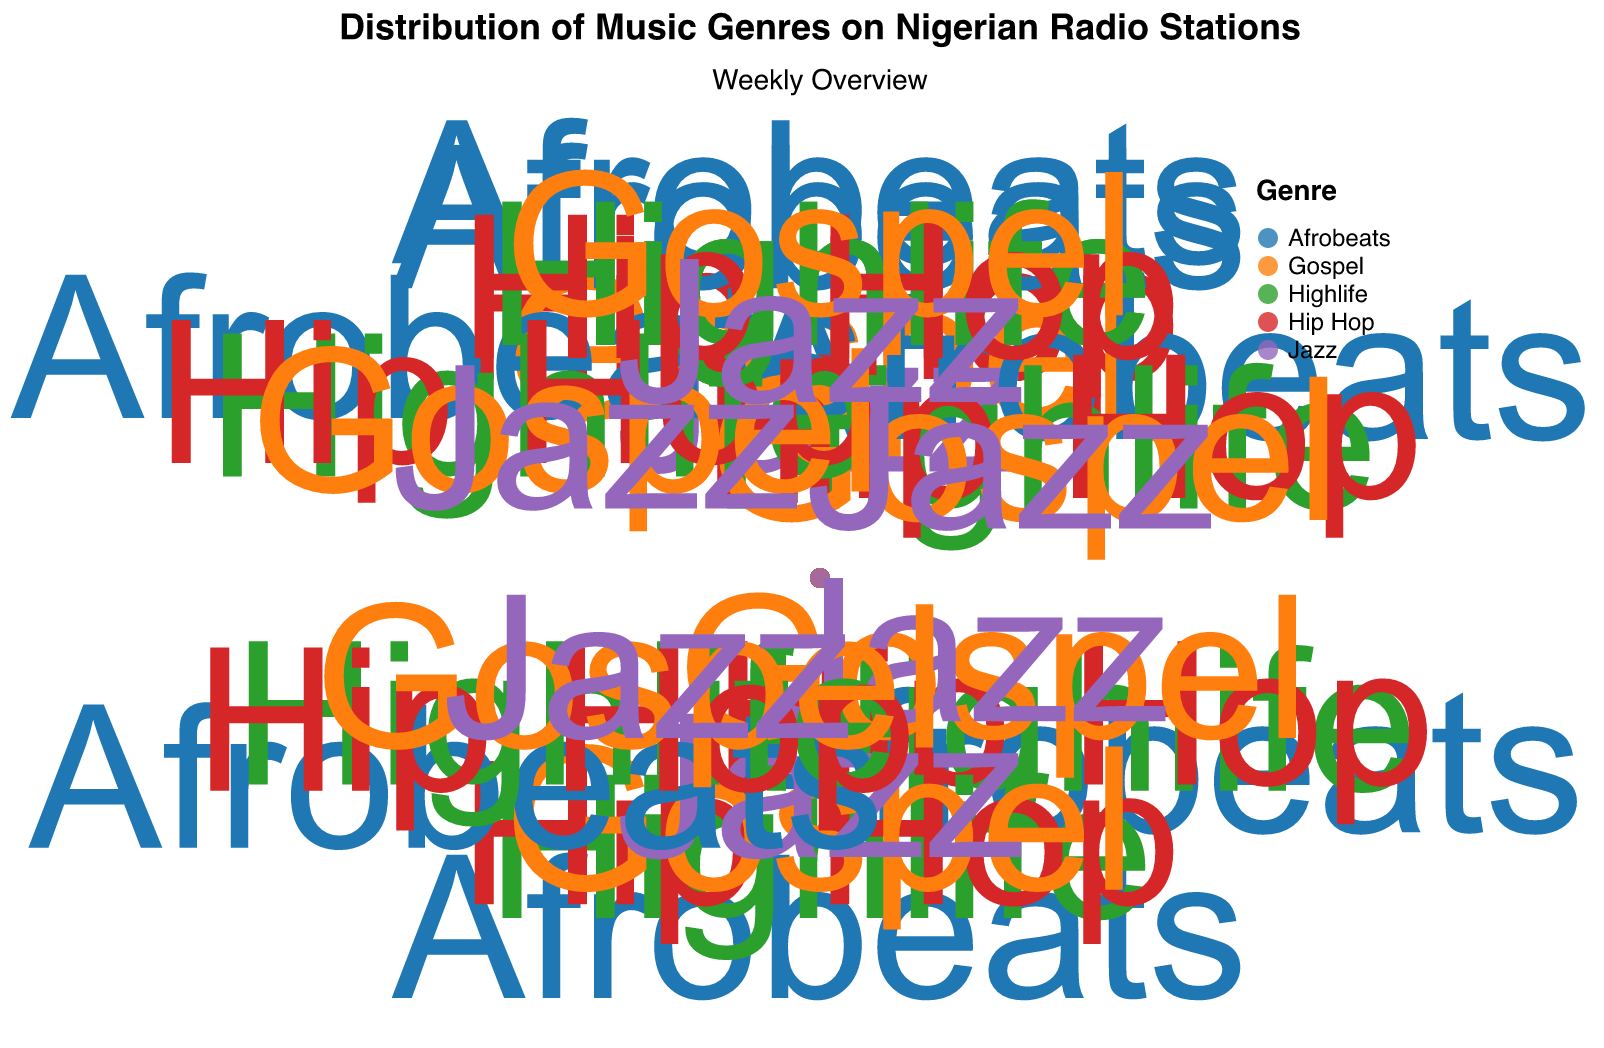What is the most frequently played genre on Monday? The points on Monday show Afrobeats with the highest frequency at 35.
Answer: Afrobeats What is the average frequency of Gospel music played from Monday to Friday? Sum the frequencies for Gospel music from Monday to Friday: 10 + 12 + 8 + 14 + 10 = 54, then divide by 5 to get the average: 54/5.
Answer: 10.8 Which day has the highest frequency of Jazz music? Check the frequencies of Jazz music on all days; Saturday has the highest frequency at 15.
Answer: Saturday How does the frequency of Afrobeats on Thursday compare to its frequency on Saturday? The frequency of Afrobeats on Thursday is 32, and on Saturday it is 50. Comparing these, Saturday has a higher frequency.
Answer: Saturday What is the total frequency of Highlife music played on the weekend (Saturday and Sunday)? Sum the frequencies of Highlife on Saturday (25) and Sunday (20): 25 + 20 = 45.
Answer: 45 Which genre sees the most significant increase in plays from Monday to Saturday? For each genre, calculate the difference in frequency from Monday to Saturday: Afrobeats (50-35=15), Highlife (25-20=5), Hip Hop (30-15=15), Gospel (20-10=10), Jazz (15-5=10). Both Afrobeats and Hip Hop have an increase of 15.
Answer: Afrobeats and Hip Hop What is the average frequency of all genres played on Wednesday? Sum the frequencies for all genres on Wednesday: Afrobeats (38) + Highlife (22) + Hip Hop (20) + Gospel (8) + Jazz (5) = 93. Divide by the number of genres (5): 93/5 = 18.6.
Answer: 18.6 Which genre has the smallest variation in frequency throughout the week? Calculate the range for each genre (max - min): Afrobeats (50-30=20), Highlife (25-15=10), Hip Hop (30-15=15), Gospel (25-8=17), Jazz (15-5=10). Highlife and Jazz both have the smallest variation of 10.
Answer: Highlife and Jazz Do any genres have their highest play frequency on a weekday? Check each genre's highest frequency: Afrobeats (Saturday 50), Highlife (Saturday 25), Hip Hop (Saturday 30), Gospel (Sunday 25), Jazz (Saturday 15). No genre has its highest frequency on a weekday.
Answer: No What is the difference in the frequency of Jazz music between Tuesday and Thursday? The frequency of Jazz on Tuesday is 10, and on Thursday it is also 10. The difference is 10 - 10 = 0.
Answer: 0 